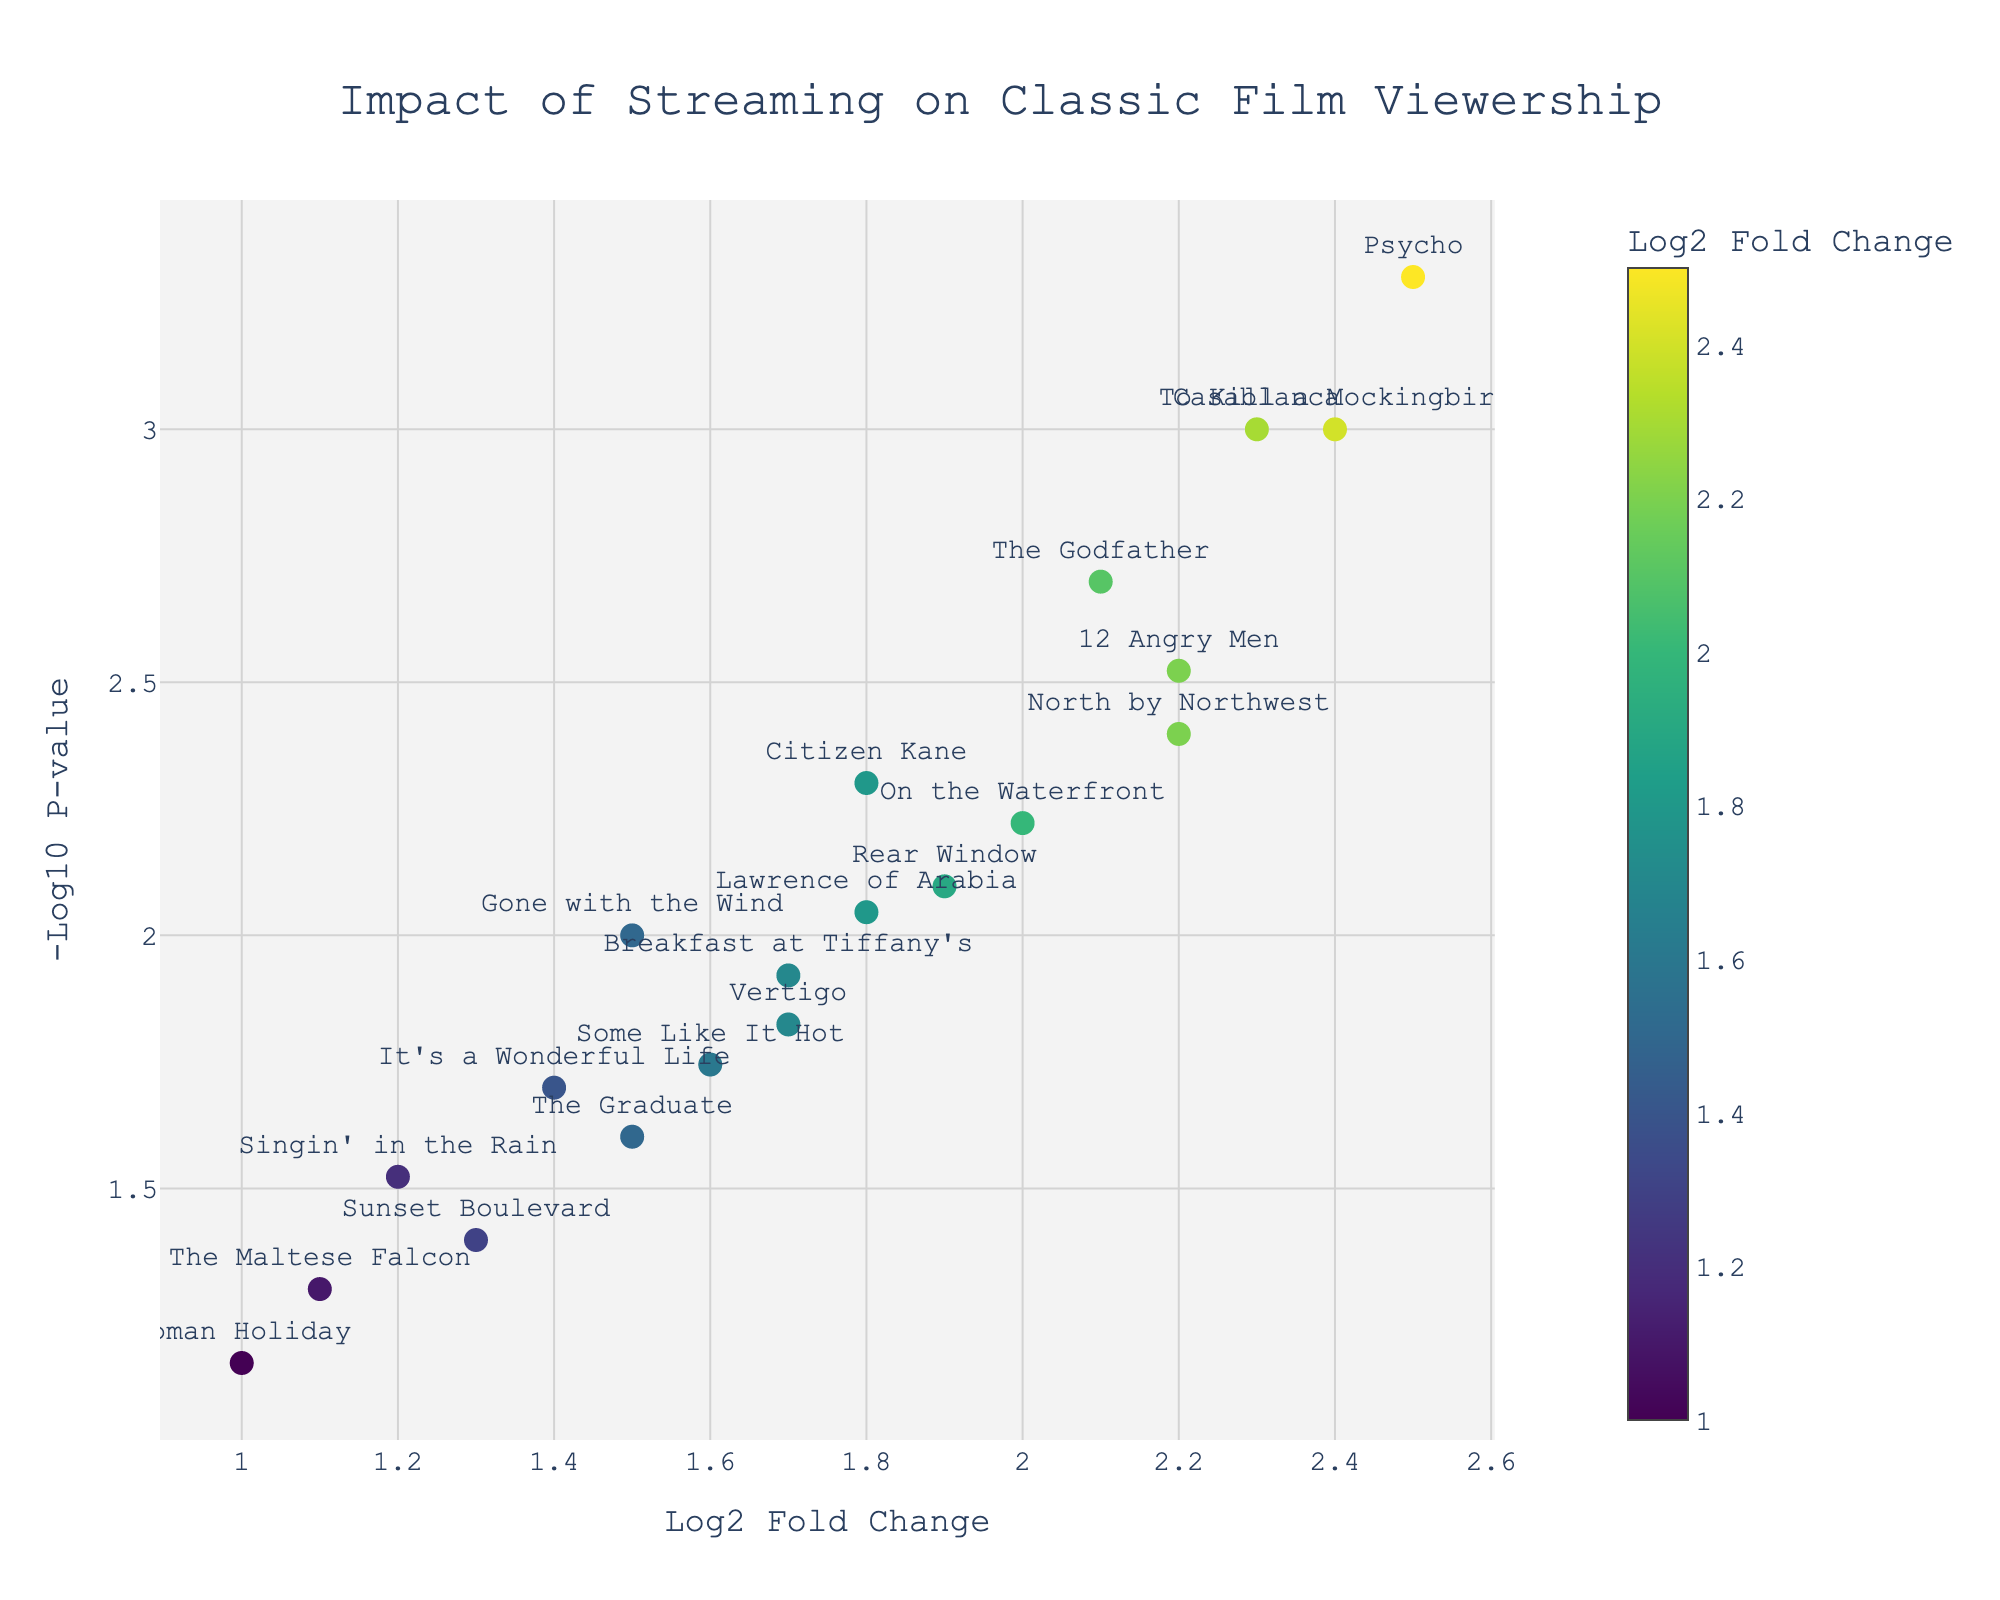What is the title of the plot? The title is prominently displayed at the top of the figure.
Answer: Impact of Streaming on Classic Film Viewership How many films are shown in the plot? Each film is represented by a data point on the plot; counting all data points will give the answer.
Answer: 20 Which film has the highest increase in viewership based on the log2 fold change? The film with the highest log2 fold change value has the most increase. In the plot, this can be identified by finding the highest point along the x-axis (log2 fold change).
Answer: Psycho What is the significance level of "Casablanca" in terms of p-value? By locating where "Casablanca" is plotted, and referring to its corresponding y-position on the plot (-log10 P-value), you can find its significance level. The lower the p-value, the more significant the result.
Answer: 0.001 What does a higher -log10 p-value indicate in terms of significance? A higher -log10 p-value corresponds to a lower p-value, indicating higher significance.
Answer: Higher significance Which films have a log2 fold change greater than 2.0 and a p-value less than 0.01? Look for films positioned above the 0.01 mark on the y-axis (-log10 p-value > 2) and to the right of 2.0 on the x-axis.
Answer: Casablanca, The Godfather, Psycho, 12 Angry Men, To Kill a Mockingbird, North by Northwest How does the viewership impact of "Rear Window" compare to "Vertigo"? Compare the log2 fold change and -log10 p-value of "Rear Window" and "Vertigo" on the plot.
Answer: "Rear Window" has a higher log2 fold change (1.9 vs. 1.7) What can be inferred if a film is positioned towards the upper right corner of the plot? The upper right corner indicates a high log2 fold change and a low p-value, suggesting a significant increase in viewership.
Answer: Significant increase in viewership Is "Roman Holiday" considered significant in this study? Why or why not? Check the p-value corresponding to "Roman Holiday." A film is typically considered significant if its p-value is less than 0.05.
Answer: No, its p-value is 0.07 